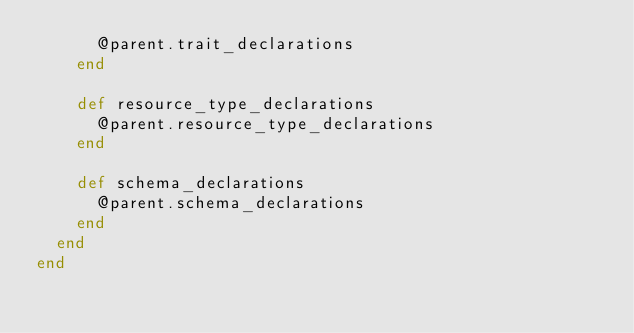<code> <loc_0><loc_0><loc_500><loc_500><_Ruby_>  		@parent.trait_declarations
  	end

  	def resource_type_declarations
  		@parent.resource_type_declarations
  	end

  	def schema_declarations
  		@parent.schema_declarations
  	end
  end
end</code> 